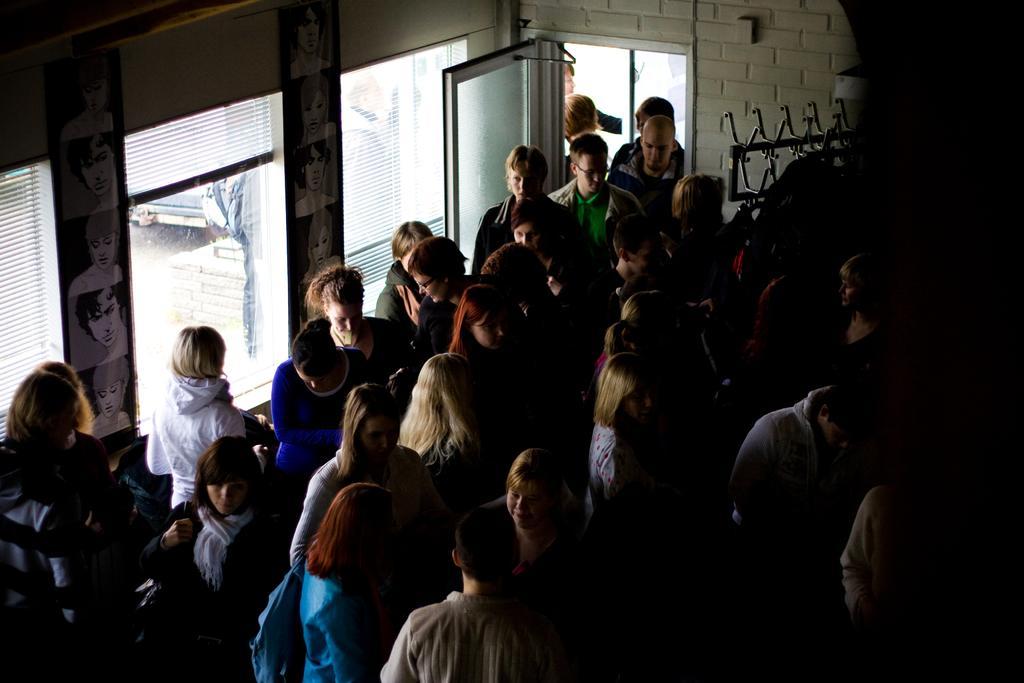In one or two sentences, can you explain what this image depicts? In this image there are group of people standing and there is one glass door, windows, blinds and through the window we could see some people. And on the right side of the image there are some objects. 